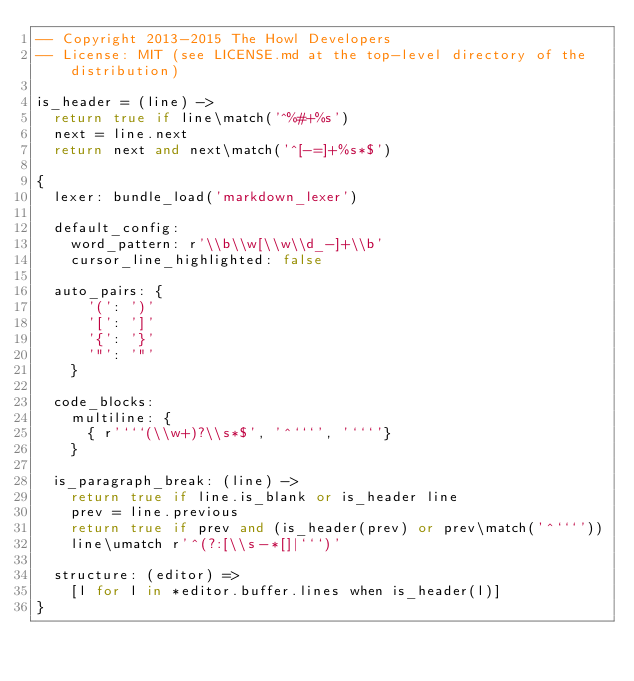<code> <loc_0><loc_0><loc_500><loc_500><_MoonScript_>-- Copyright 2013-2015 The Howl Developers
-- License: MIT (see LICENSE.md at the top-level directory of the distribution)

is_header = (line) ->
  return true if line\match('^%#+%s')
  next = line.next
  return next and next\match('^[-=]+%s*$')

{
  lexer: bundle_load('markdown_lexer')

  default_config:
    word_pattern: r'\\b\\w[\\w\\d_-]+\\b'
    cursor_line_highlighted: false

  auto_pairs: {
      '(': ')'
      '[': ']'
      '{': '}'
      '"': '"'
    }

  code_blocks:
    multiline: {
      { r'```(\\w+)?\\s*$', '^```', '```'}
    }

  is_paragraph_break: (line) ->
    return true if line.is_blank or is_header line
    prev = line.previous
    return true if prev and (is_header(prev) or prev\match('^```'))
    line\umatch r'^(?:[\\s-*[]|```)'

  structure: (editor) =>
    [l for l in *editor.buffer.lines when is_header(l)]
}
</code> 